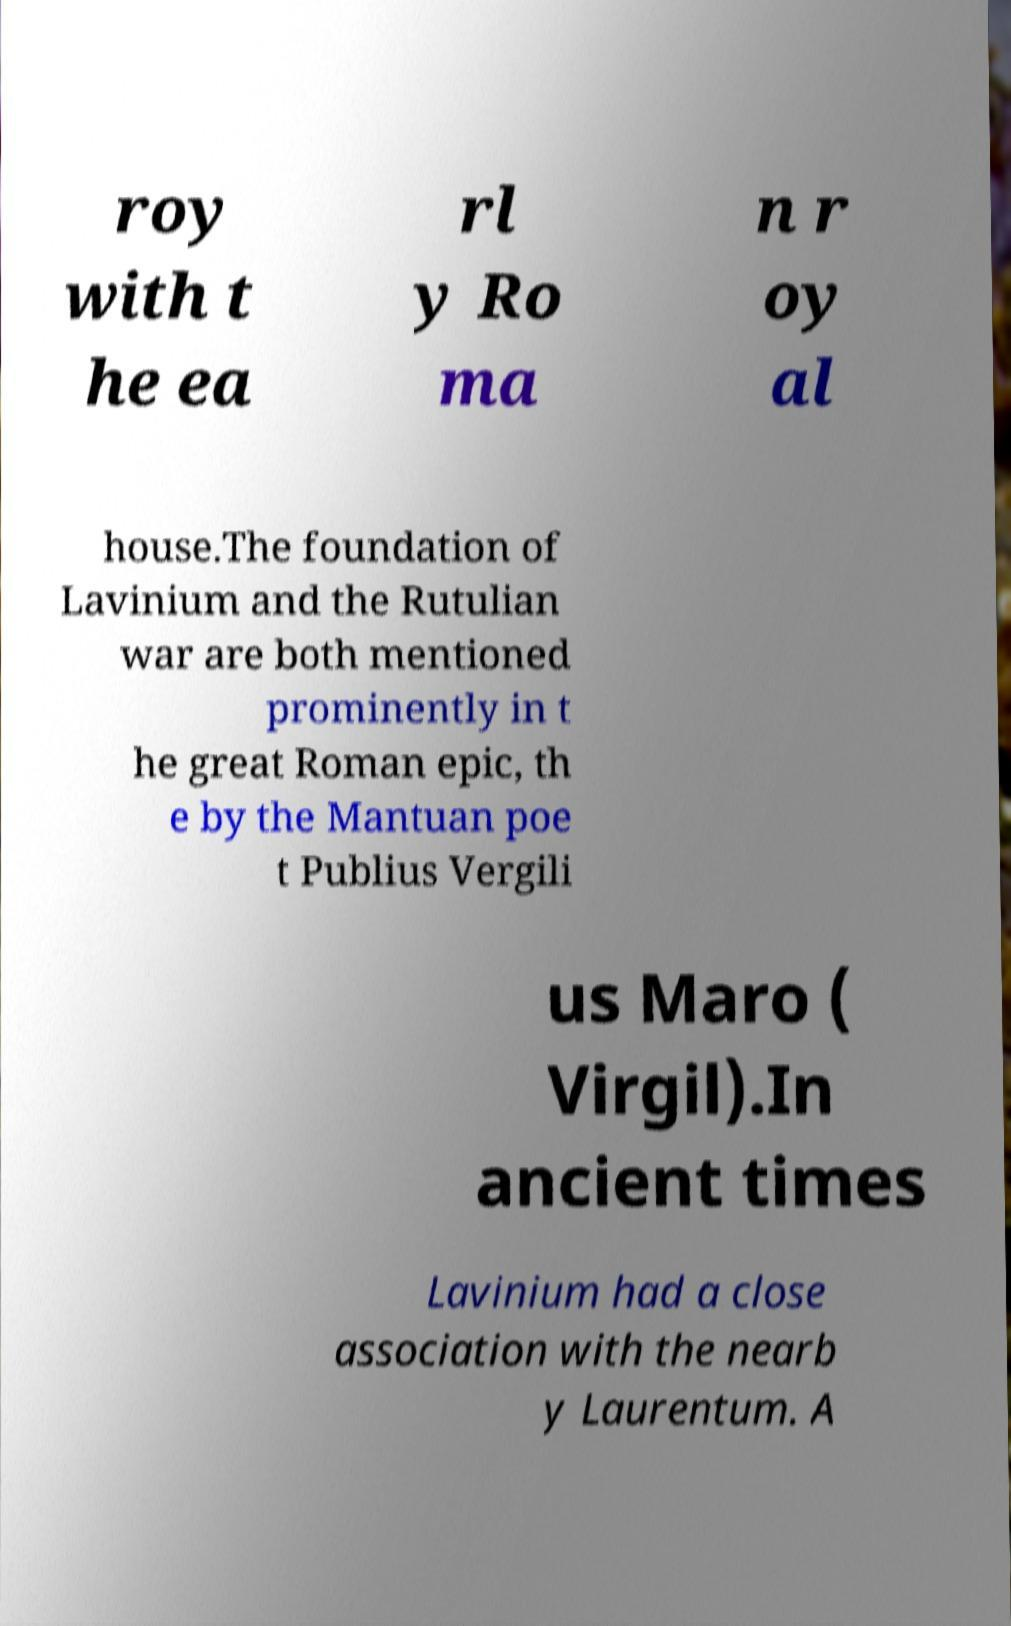Could you extract and type out the text from this image? roy with t he ea rl y Ro ma n r oy al house.The foundation of Lavinium and the Rutulian war are both mentioned prominently in t he great Roman epic, th e by the Mantuan poe t Publius Vergili us Maro ( Virgil).In ancient times Lavinium had a close association with the nearb y Laurentum. A 